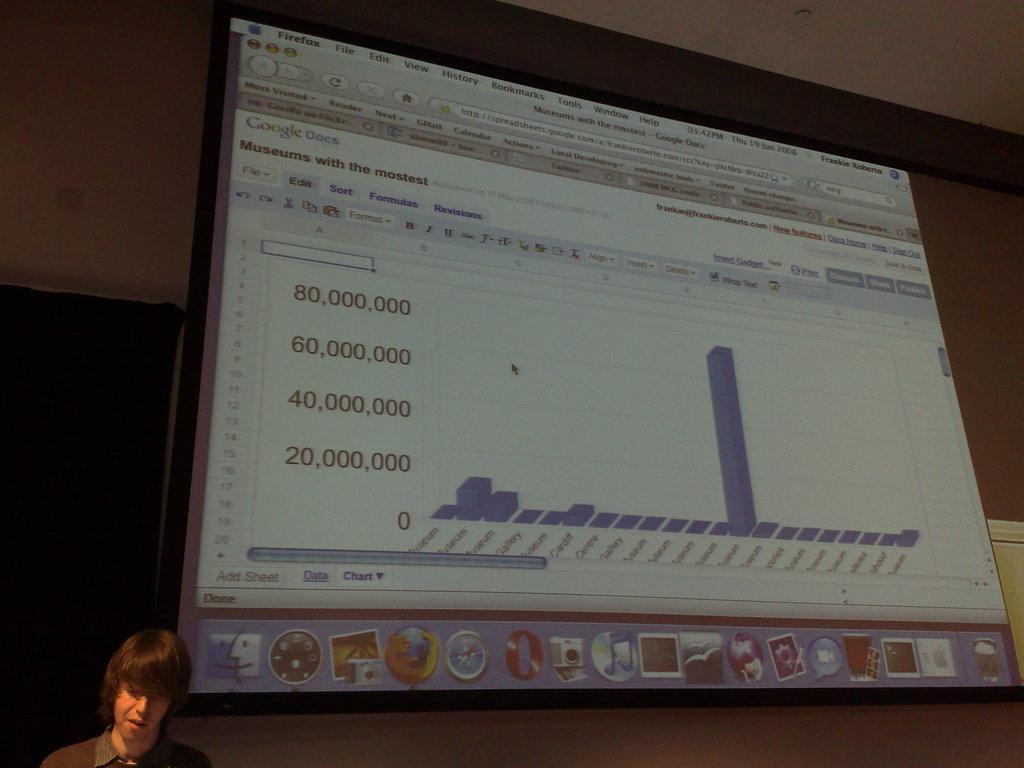Describe this image in one or two sentences. In this image there is a man, in the background there is a screen, on that screen there is a presentation. 